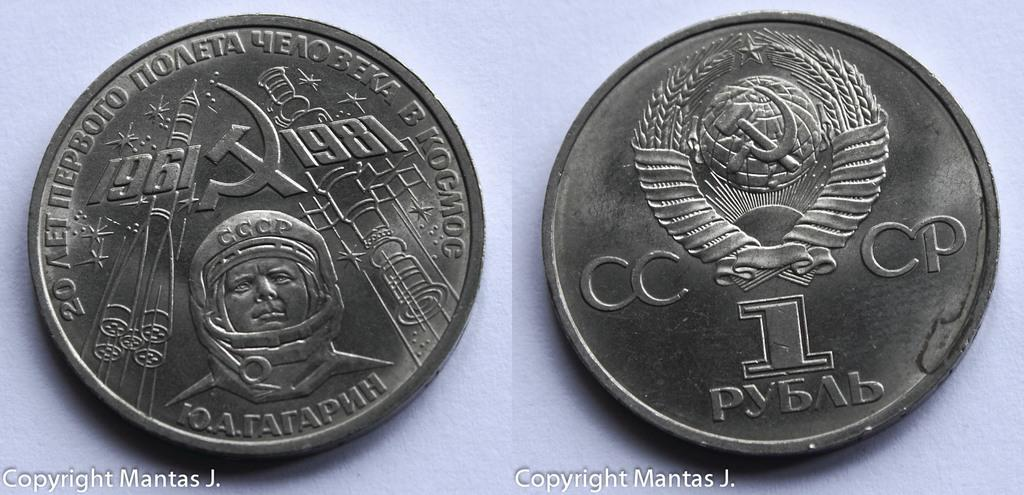<image>
Create a compact narrative representing the image presented. The front and back of a Soviet coin that commemorates an event from 1961. 